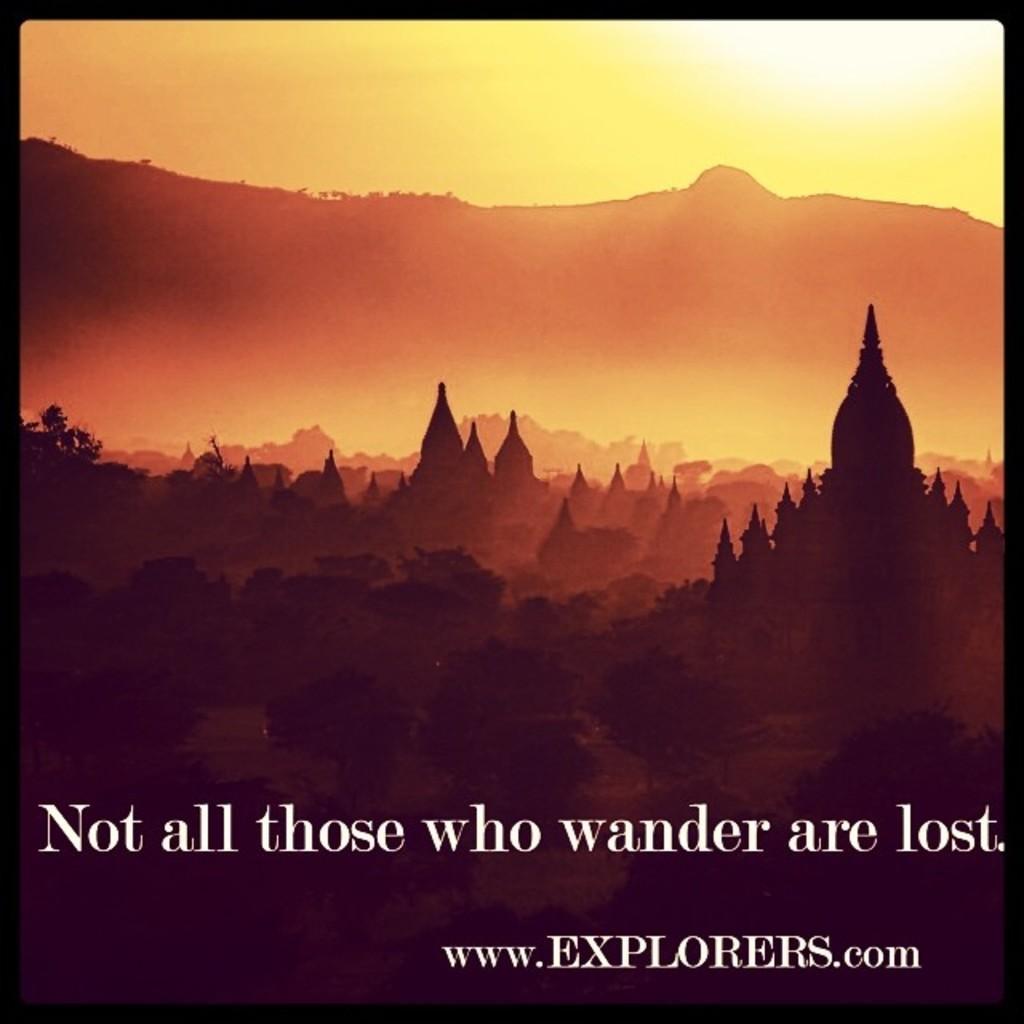Please provide a concise description of this image. In this picture we can see some text at the bottom of the picture. There is an architecture and a few plants on the left side. 